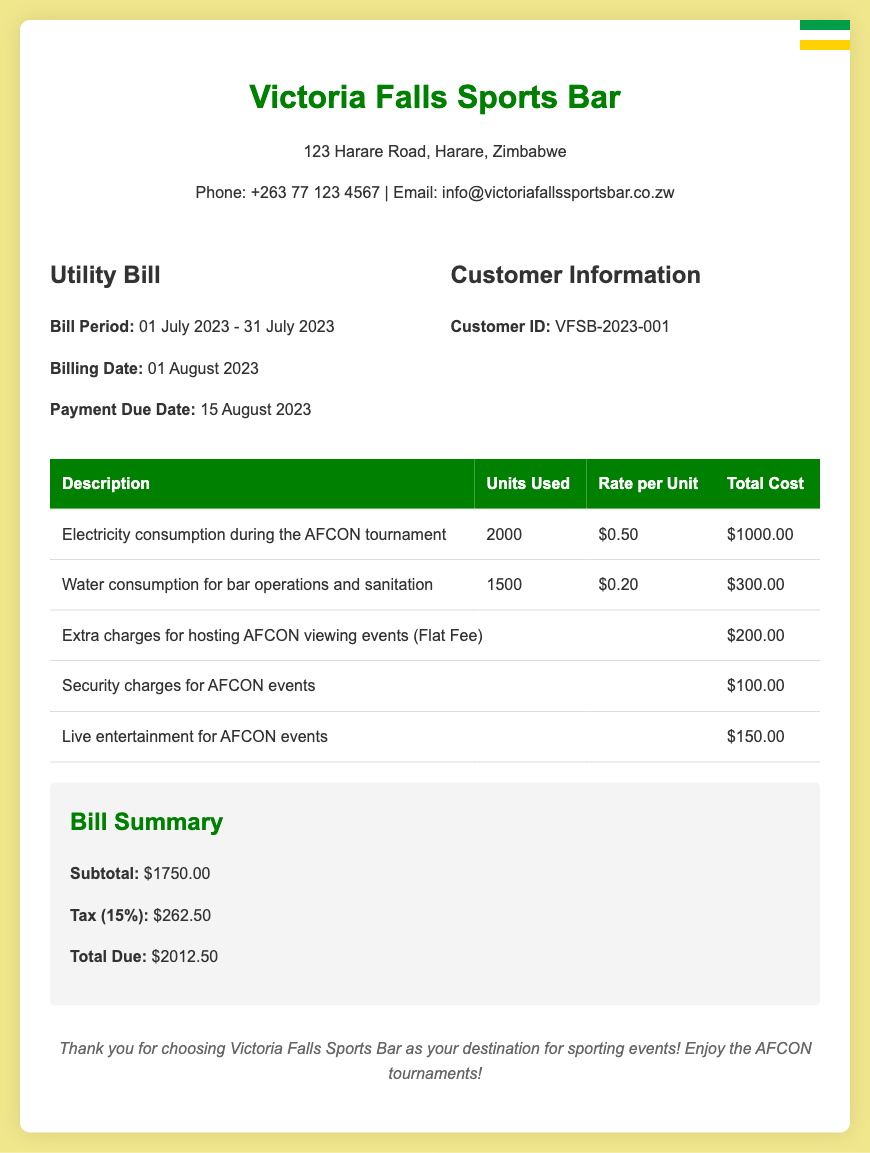What is the billing date? The billing date is clearly stated in the document as the date when the bill was generated, which is 01 August 2023.
Answer: 01 August 2023 What is the total due amount? The total due amount is calculated in the summary section of the bill. It states that the total due is $2012.50.
Answer: $2012.50 How much was charged for water consumption? The bill itemizes the charges for water consumption specifically, which amounts to $300.00.
Answer: $300.00 What was the rate per unit for electricity consumption? The document specifies the rate per unit for electricity consumption, which is $0.50.
Answer: $0.50 What is the subtotal before tax? The subtotal is presented in the summary before the tax is added, stated as $1750.00.
Answer: $1750.00 How many units of electricity were consumed? The bill outlines the electricity consumption, resulting in a total of 2000 units used.
Answer: 2000 What is the tax percentage applied to the bill? The tax percentage is mentioned in the summary as 15%.
Answer: 15% What was the extra charge for hosting AFCON viewing events? The extra charge for hosting AFCON viewing events is provided as a flat fee of $200.00.
Answer: $200.00 What is the customer ID for this bill? The customer ID is an important identifier included in the customer details section, which is VFSB-2023-001.
Answer: VFSB-2023-001 